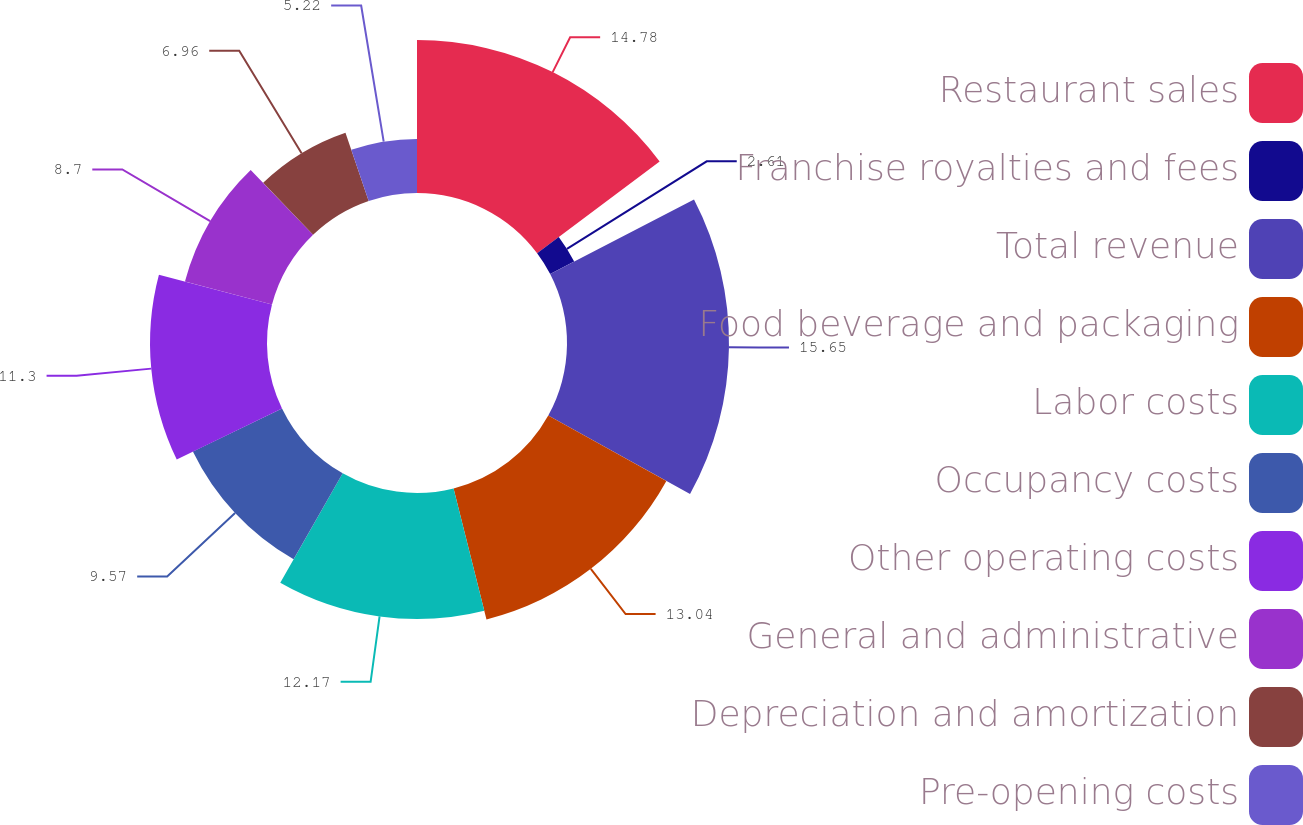Convert chart to OTSL. <chart><loc_0><loc_0><loc_500><loc_500><pie_chart><fcel>Restaurant sales<fcel>Franchise royalties and fees<fcel>Total revenue<fcel>Food beverage and packaging<fcel>Labor costs<fcel>Occupancy costs<fcel>Other operating costs<fcel>General and administrative<fcel>Depreciation and amortization<fcel>Pre-opening costs<nl><fcel>14.78%<fcel>2.61%<fcel>15.65%<fcel>13.04%<fcel>12.17%<fcel>9.57%<fcel>11.3%<fcel>8.7%<fcel>6.96%<fcel>5.22%<nl></chart> 